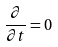<formula> <loc_0><loc_0><loc_500><loc_500>\frac { \partial } { \partial t } = 0</formula> 